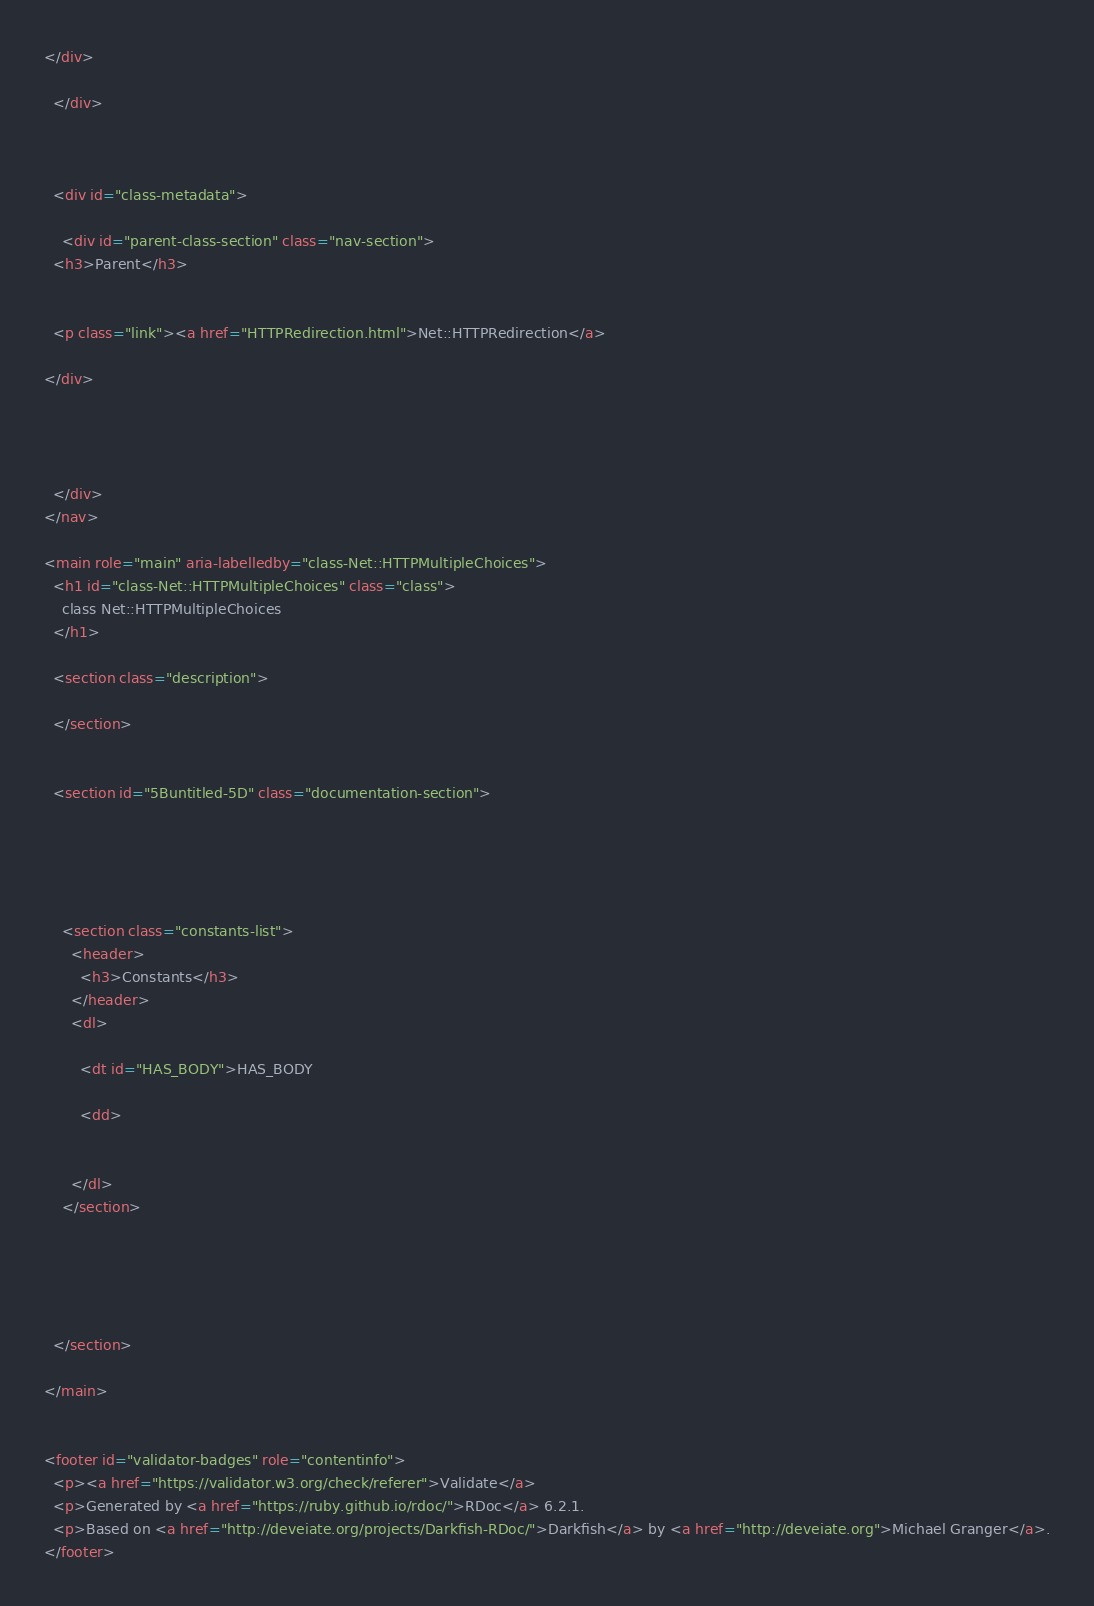<code> <loc_0><loc_0><loc_500><loc_500><_HTML_></div>

  </div>

  

  <div id="class-metadata">
    
    <div id="parent-class-section" class="nav-section">
  <h3>Parent</h3>

  
  <p class="link"><a href="HTTPRedirection.html">Net::HTTPRedirection</a>
  
</div>

    
    
    
  </div>
</nav>

<main role="main" aria-labelledby="class-Net::HTTPMultipleChoices">
  <h1 id="class-Net::HTTPMultipleChoices" class="class">
    class Net::HTTPMultipleChoices
  </h1>

  <section class="description">
    
  </section>

  
  <section id="5Buntitled-5D" class="documentation-section">
    

    

    
    <section class="constants-list">
      <header>
        <h3>Constants</h3>
      </header>
      <dl>
      
        <dt id="HAS_BODY">HAS_BODY
        
        <dd>
        
      
      </dl>
    </section>
    

    

    
  </section>

</main>


<footer id="validator-badges" role="contentinfo">
  <p><a href="https://validator.w3.org/check/referer">Validate</a>
  <p>Generated by <a href="https://ruby.github.io/rdoc/">RDoc</a> 6.2.1.
  <p>Based on <a href="http://deveiate.org/projects/Darkfish-RDoc/">Darkfish</a> by <a href="http://deveiate.org">Michael Granger</a>.
</footer>

</code> 